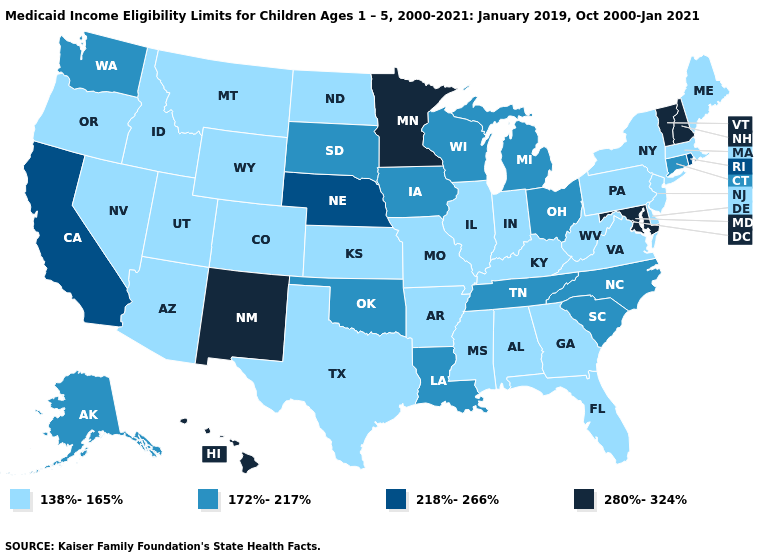Is the legend a continuous bar?
Give a very brief answer. No. How many symbols are there in the legend?
Short answer required. 4. Is the legend a continuous bar?
Answer briefly. No. What is the lowest value in states that border Connecticut?
Concise answer only. 138%-165%. Among the states that border South Carolina , does North Carolina have the highest value?
Concise answer only. Yes. Name the states that have a value in the range 280%-324%?
Concise answer only. Hawaii, Maryland, Minnesota, New Hampshire, New Mexico, Vermont. Is the legend a continuous bar?
Quick response, please. No. Name the states that have a value in the range 172%-217%?
Answer briefly. Alaska, Connecticut, Iowa, Louisiana, Michigan, North Carolina, Ohio, Oklahoma, South Carolina, South Dakota, Tennessee, Washington, Wisconsin. What is the highest value in the West ?
Short answer required. 280%-324%. What is the value of Nevada?
Quick response, please. 138%-165%. Name the states that have a value in the range 138%-165%?
Short answer required. Alabama, Arizona, Arkansas, Colorado, Delaware, Florida, Georgia, Idaho, Illinois, Indiana, Kansas, Kentucky, Maine, Massachusetts, Mississippi, Missouri, Montana, Nevada, New Jersey, New York, North Dakota, Oregon, Pennsylvania, Texas, Utah, Virginia, West Virginia, Wyoming. Among the states that border South Carolina , which have the highest value?
Be succinct. North Carolina. Among the states that border Rhode Island , does Connecticut have the highest value?
Concise answer only. Yes. Name the states that have a value in the range 280%-324%?
Give a very brief answer. Hawaii, Maryland, Minnesota, New Hampshire, New Mexico, Vermont. Name the states that have a value in the range 280%-324%?
Quick response, please. Hawaii, Maryland, Minnesota, New Hampshire, New Mexico, Vermont. 